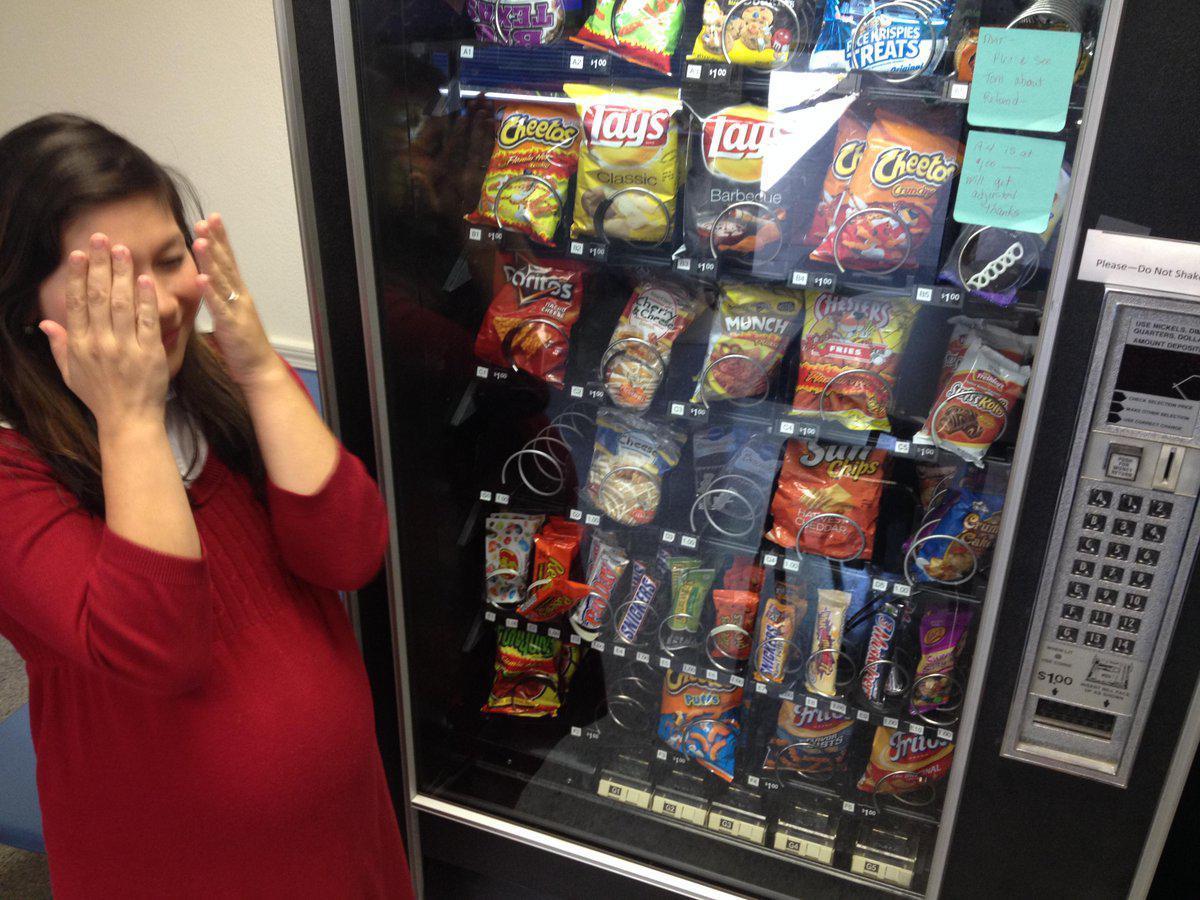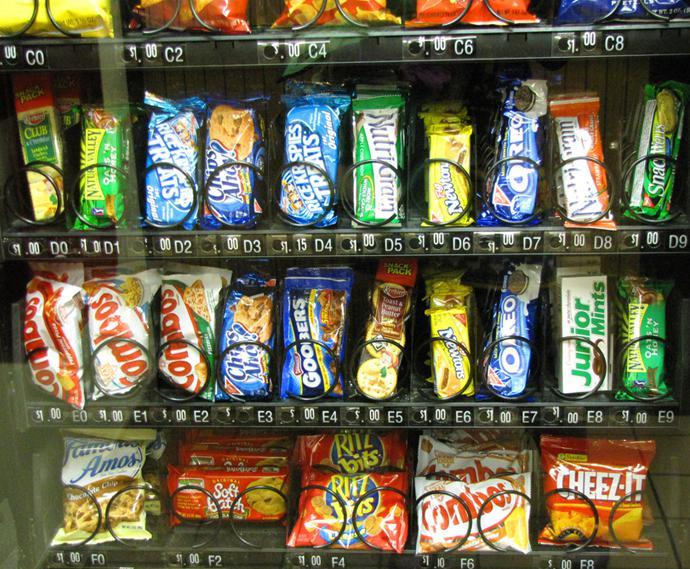The first image is the image on the left, the second image is the image on the right. Assess this claim about the two images: "A part of a human being's body is near a vending machine.". Correct or not? Answer yes or no. Yes. The first image is the image on the left, the second image is the image on the right. For the images displayed, is the sentence "Left image shows one vending machine displayed straight-on instead of at any angle." factually correct? Answer yes or no. No. 